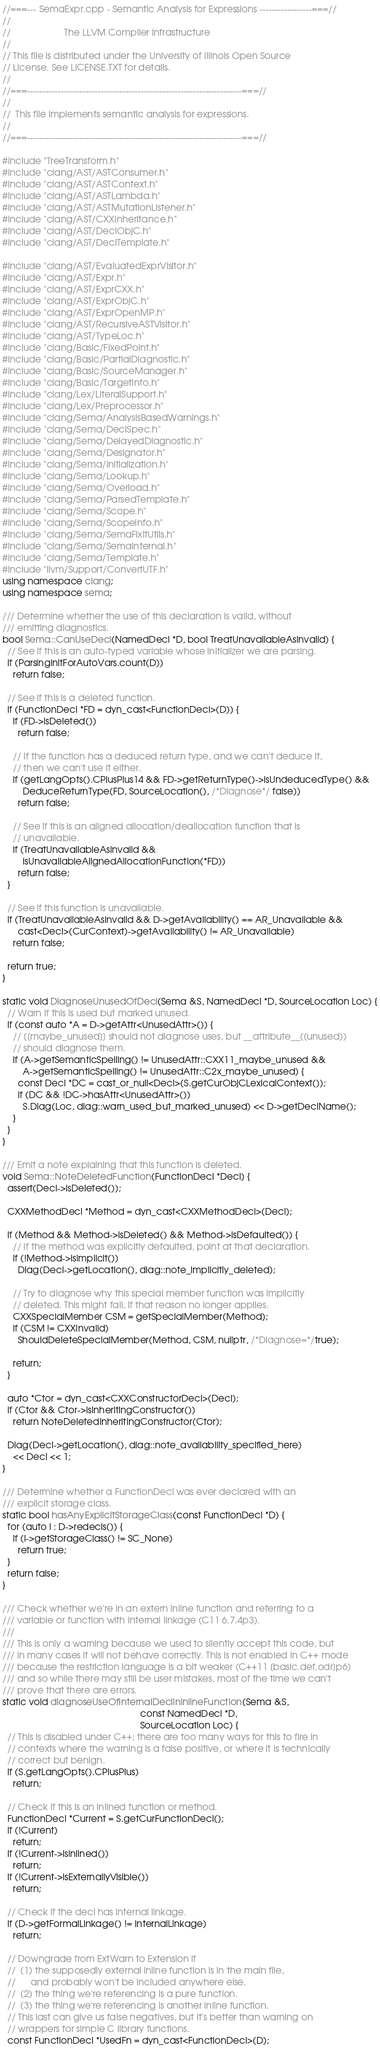Convert code to text. <code><loc_0><loc_0><loc_500><loc_500><_C++_>//===--- SemaExpr.cpp - Semantic Analysis for Expressions -----------------===//
//
//                     The LLVM Compiler Infrastructure
//
// This file is distributed under the University of Illinois Open Source
// License. See LICENSE.TXT for details.
//
//===----------------------------------------------------------------------===//
//
//  This file implements semantic analysis for expressions.
//
//===----------------------------------------------------------------------===//

#include "TreeTransform.h"
#include "clang/AST/ASTConsumer.h"
#include "clang/AST/ASTContext.h"
#include "clang/AST/ASTLambda.h"
#include "clang/AST/ASTMutationListener.h"
#include "clang/AST/CXXInheritance.h"
#include "clang/AST/DeclObjC.h"
#include "clang/AST/DeclTemplate.h"

#include "clang/AST/EvaluatedExprVisitor.h"
#include "clang/AST/Expr.h"
#include "clang/AST/ExprCXX.h"
#include "clang/AST/ExprObjC.h"
#include "clang/AST/ExprOpenMP.h"
#include "clang/AST/RecursiveASTVisitor.h"
#include "clang/AST/TypeLoc.h"
#include "clang/Basic/FixedPoint.h"
#include "clang/Basic/PartialDiagnostic.h"
#include "clang/Basic/SourceManager.h"
#include "clang/Basic/TargetInfo.h"
#include "clang/Lex/LiteralSupport.h"
#include "clang/Lex/Preprocessor.h"
#include "clang/Sema/AnalysisBasedWarnings.h"
#include "clang/Sema/DeclSpec.h"
#include "clang/Sema/DelayedDiagnostic.h"
#include "clang/Sema/Designator.h"
#include "clang/Sema/Initialization.h"
#include "clang/Sema/Lookup.h"
#include "clang/Sema/Overload.h"
#include "clang/Sema/ParsedTemplate.h"
#include "clang/Sema/Scope.h"
#include "clang/Sema/ScopeInfo.h"
#include "clang/Sema/SemaFixItUtils.h"
#include "clang/Sema/SemaInternal.h"
#include "clang/Sema/Template.h"
#include "llvm/Support/ConvertUTF.h"
using namespace clang;
using namespace sema;

/// Determine whether the use of this declaration is valid, without
/// emitting diagnostics.
bool Sema::CanUseDecl(NamedDecl *D, bool TreatUnavailableAsInvalid) {
  // See if this is an auto-typed variable whose initializer we are parsing.
  if (ParsingInitForAutoVars.count(D))
    return false;

  // See if this is a deleted function.
  if (FunctionDecl *FD = dyn_cast<FunctionDecl>(D)) {
    if (FD->isDeleted())
      return false;

    // If the function has a deduced return type, and we can't deduce it,
    // then we can't use it either.
    if (getLangOpts().CPlusPlus14 && FD->getReturnType()->isUndeducedType() &&
        DeduceReturnType(FD, SourceLocation(), /*Diagnose*/ false))
      return false;

    // See if this is an aligned allocation/deallocation function that is
    // unavailable.
    if (TreatUnavailableAsInvalid &&
        isUnavailableAlignedAllocationFunction(*FD))
      return false;
  }

  // See if this function is unavailable.
  if (TreatUnavailableAsInvalid && D->getAvailability() == AR_Unavailable &&
      cast<Decl>(CurContext)->getAvailability() != AR_Unavailable)
    return false;

  return true;
}

static void DiagnoseUnusedOfDecl(Sema &S, NamedDecl *D, SourceLocation Loc) {
  // Warn if this is used but marked unused.
  if (const auto *A = D->getAttr<UnusedAttr>()) {
    // [[maybe_unused]] should not diagnose uses, but __attribute__((unused))
    // should diagnose them.
    if (A->getSemanticSpelling() != UnusedAttr::CXX11_maybe_unused &&
        A->getSemanticSpelling() != UnusedAttr::C2x_maybe_unused) {
      const Decl *DC = cast_or_null<Decl>(S.getCurObjCLexicalContext());
      if (DC && !DC->hasAttr<UnusedAttr>())
        S.Diag(Loc, diag::warn_used_but_marked_unused) << D->getDeclName();
    }
  }
}

/// Emit a note explaining that this function is deleted.
void Sema::NoteDeletedFunction(FunctionDecl *Decl) {
  assert(Decl->isDeleted());

  CXXMethodDecl *Method = dyn_cast<CXXMethodDecl>(Decl);

  if (Method && Method->isDeleted() && Method->isDefaulted()) {
    // If the method was explicitly defaulted, point at that declaration.
    if (!Method->isImplicit())
      Diag(Decl->getLocation(), diag::note_implicitly_deleted);

    // Try to diagnose why this special member function was implicitly
    // deleted. This might fail, if that reason no longer applies.
    CXXSpecialMember CSM = getSpecialMember(Method);
    if (CSM != CXXInvalid)
      ShouldDeleteSpecialMember(Method, CSM, nullptr, /*Diagnose=*/true);

    return;
  }

  auto *Ctor = dyn_cast<CXXConstructorDecl>(Decl);
  if (Ctor && Ctor->isInheritingConstructor())
    return NoteDeletedInheritingConstructor(Ctor);

  Diag(Decl->getLocation(), diag::note_availability_specified_here)
    << Decl << 1;
}

/// Determine whether a FunctionDecl was ever declared with an
/// explicit storage class.
static bool hasAnyExplicitStorageClass(const FunctionDecl *D) {
  for (auto I : D->redecls()) {
    if (I->getStorageClass() != SC_None)
      return true;
  }
  return false;
}

/// Check whether we're in an extern inline function and referring to a
/// variable or function with internal linkage (C11 6.7.4p3).
///
/// This is only a warning because we used to silently accept this code, but
/// in many cases it will not behave correctly. This is not enabled in C++ mode
/// because the restriction language is a bit weaker (C++11 [basic.def.odr]p6)
/// and so while there may still be user mistakes, most of the time we can't
/// prove that there are errors.
static void diagnoseUseOfInternalDeclInInlineFunction(Sema &S,
                                                      const NamedDecl *D,
                                                      SourceLocation Loc) {
  // This is disabled under C++; there are too many ways for this to fire in
  // contexts where the warning is a false positive, or where it is technically
  // correct but benign.
  if (S.getLangOpts().CPlusPlus)
    return;

  // Check if this is an inlined function or method.
  FunctionDecl *Current = S.getCurFunctionDecl();
  if (!Current)
    return;
  if (!Current->isInlined())
    return;
  if (!Current->isExternallyVisible())
    return;

  // Check if the decl has internal linkage.
  if (D->getFormalLinkage() != InternalLinkage)
    return;

  // Downgrade from ExtWarn to Extension if
  //  (1) the supposedly external inline function is in the main file,
  //      and probably won't be included anywhere else.
  //  (2) the thing we're referencing is a pure function.
  //  (3) the thing we're referencing is another inline function.
  // This last can give us false negatives, but it's better than warning on
  // wrappers for simple C library functions.
  const FunctionDecl *UsedFn = dyn_cast<FunctionDecl>(D);</code> 